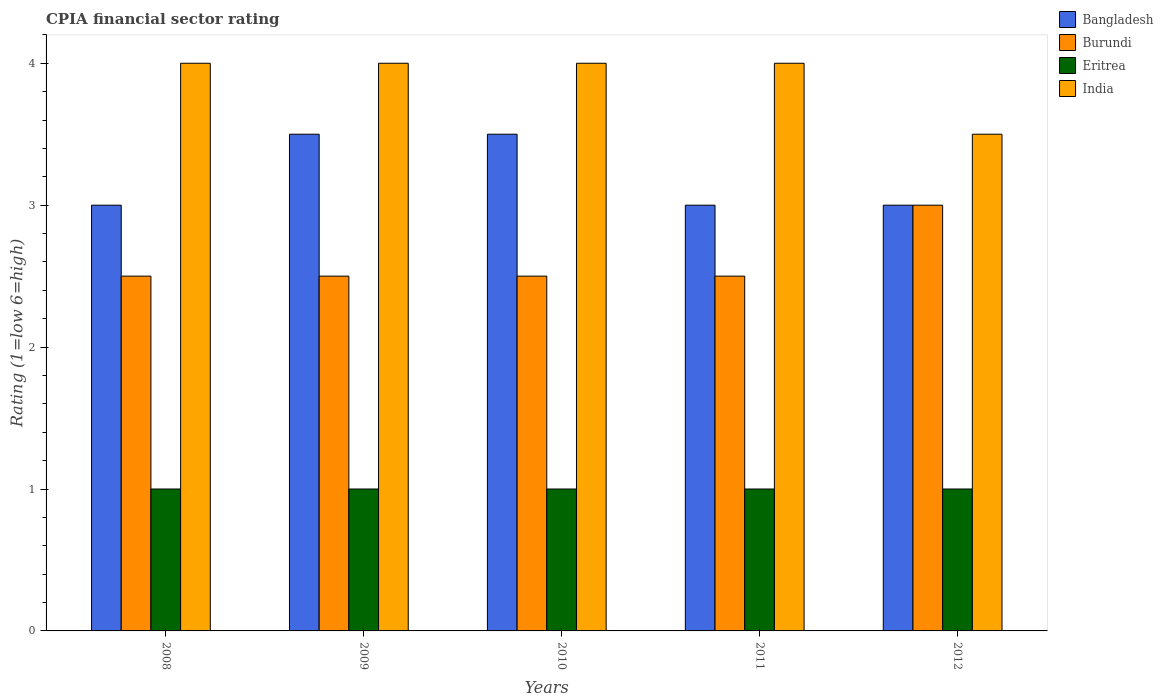How many bars are there on the 4th tick from the right?
Your answer should be very brief. 4. In how many cases, is the number of bars for a given year not equal to the number of legend labels?
Offer a very short reply. 0. What is the total CPIA rating in Bangladesh in the graph?
Your answer should be compact. 16. What is the difference between the CPIA rating in Eritrea in 2009 and that in 2010?
Your answer should be very brief. 0. What is the difference between the CPIA rating in Burundi in 2011 and the CPIA rating in Bangladesh in 2009?
Your response must be concise. -1. What is the average CPIA rating in Eritrea per year?
Your answer should be compact. 1. In the year 2012, what is the difference between the CPIA rating in Eritrea and CPIA rating in Bangladesh?
Your answer should be compact. -2. What is the ratio of the CPIA rating in Eritrea in 2009 to that in 2012?
Give a very brief answer. 1. What is the difference between the highest and the second highest CPIA rating in Eritrea?
Give a very brief answer. 0. What does the 2nd bar from the left in 2008 represents?
Your answer should be very brief. Burundi. What does the 4th bar from the right in 2012 represents?
Your response must be concise. Bangladesh. Is it the case that in every year, the sum of the CPIA rating in Bangladesh and CPIA rating in India is greater than the CPIA rating in Eritrea?
Keep it short and to the point. Yes. How many bars are there?
Provide a succinct answer. 20. How many years are there in the graph?
Provide a succinct answer. 5. What is the difference between two consecutive major ticks on the Y-axis?
Ensure brevity in your answer.  1. What is the title of the graph?
Give a very brief answer. CPIA financial sector rating. Does "Samoa" appear as one of the legend labels in the graph?
Ensure brevity in your answer.  No. What is the label or title of the X-axis?
Your answer should be very brief. Years. What is the label or title of the Y-axis?
Offer a very short reply. Rating (1=low 6=high). What is the Rating (1=low 6=high) of Eritrea in 2008?
Keep it short and to the point. 1. What is the Rating (1=low 6=high) in Eritrea in 2009?
Provide a succinct answer. 1. What is the Rating (1=low 6=high) in Burundi in 2010?
Provide a short and direct response. 2.5. What is the Rating (1=low 6=high) in Eritrea in 2010?
Give a very brief answer. 1. What is the Rating (1=low 6=high) of India in 2010?
Keep it short and to the point. 4. What is the Rating (1=low 6=high) of Burundi in 2012?
Your response must be concise. 3. What is the Rating (1=low 6=high) in India in 2012?
Offer a terse response. 3.5. Across all years, what is the maximum Rating (1=low 6=high) of Bangladesh?
Ensure brevity in your answer.  3.5. Across all years, what is the maximum Rating (1=low 6=high) of Burundi?
Give a very brief answer. 3. Across all years, what is the maximum Rating (1=low 6=high) in Eritrea?
Your response must be concise. 1. Across all years, what is the maximum Rating (1=low 6=high) of India?
Give a very brief answer. 4. Across all years, what is the minimum Rating (1=low 6=high) of Bangladesh?
Provide a succinct answer. 3. Across all years, what is the minimum Rating (1=low 6=high) of Eritrea?
Offer a very short reply. 1. What is the total Rating (1=low 6=high) of Bangladesh in the graph?
Keep it short and to the point. 16. What is the total Rating (1=low 6=high) in Eritrea in the graph?
Provide a short and direct response. 5. What is the difference between the Rating (1=low 6=high) of Eritrea in 2008 and that in 2009?
Provide a succinct answer. 0. What is the difference between the Rating (1=low 6=high) in Bangladesh in 2008 and that in 2010?
Your answer should be very brief. -0.5. What is the difference between the Rating (1=low 6=high) in Eritrea in 2008 and that in 2010?
Your response must be concise. 0. What is the difference between the Rating (1=low 6=high) in India in 2008 and that in 2010?
Offer a very short reply. 0. What is the difference between the Rating (1=low 6=high) in India in 2008 and that in 2011?
Offer a very short reply. 0. What is the difference between the Rating (1=low 6=high) in Bangladesh in 2008 and that in 2012?
Provide a succinct answer. 0. What is the difference between the Rating (1=low 6=high) of Eritrea in 2008 and that in 2012?
Provide a short and direct response. 0. What is the difference between the Rating (1=low 6=high) of India in 2008 and that in 2012?
Keep it short and to the point. 0.5. What is the difference between the Rating (1=low 6=high) in Bangladesh in 2009 and that in 2010?
Provide a short and direct response. 0. What is the difference between the Rating (1=low 6=high) in Eritrea in 2009 and that in 2010?
Keep it short and to the point. 0. What is the difference between the Rating (1=low 6=high) in Burundi in 2009 and that in 2011?
Your answer should be very brief. 0. What is the difference between the Rating (1=low 6=high) of Bangladesh in 2009 and that in 2012?
Give a very brief answer. 0.5. What is the difference between the Rating (1=low 6=high) of India in 2009 and that in 2012?
Offer a terse response. 0.5. What is the difference between the Rating (1=low 6=high) in Bangladesh in 2010 and that in 2011?
Provide a short and direct response. 0.5. What is the difference between the Rating (1=low 6=high) of India in 2010 and that in 2011?
Offer a very short reply. 0. What is the difference between the Rating (1=low 6=high) in Burundi in 2010 and that in 2012?
Ensure brevity in your answer.  -0.5. What is the difference between the Rating (1=low 6=high) in Eritrea in 2010 and that in 2012?
Your answer should be compact. 0. What is the difference between the Rating (1=low 6=high) in Eritrea in 2011 and that in 2012?
Your response must be concise. 0. What is the difference between the Rating (1=low 6=high) of India in 2011 and that in 2012?
Provide a succinct answer. 0.5. What is the difference between the Rating (1=low 6=high) in Bangladesh in 2008 and the Rating (1=low 6=high) in Burundi in 2009?
Ensure brevity in your answer.  0.5. What is the difference between the Rating (1=low 6=high) of Burundi in 2008 and the Rating (1=low 6=high) of India in 2009?
Your response must be concise. -1.5. What is the difference between the Rating (1=low 6=high) of Eritrea in 2008 and the Rating (1=low 6=high) of India in 2009?
Give a very brief answer. -3. What is the difference between the Rating (1=low 6=high) in Bangladesh in 2008 and the Rating (1=low 6=high) in Burundi in 2010?
Your response must be concise. 0.5. What is the difference between the Rating (1=low 6=high) of Bangladesh in 2008 and the Rating (1=low 6=high) of Eritrea in 2010?
Provide a succinct answer. 2. What is the difference between the Rating (1=low 6=high) of Burundi in 2008 and the Rating (1=low 6=high) of India in 2010?
Give a very brief answer. -1.5. What is the difference between the Rating (1=low 6=high) of Eritrea in 2008 and the Rating (1=low 6=high) of India in 2010?
Your answer should be compact. -3. What is the difference between the Rating (1=low 6=high) in Burundi in 2008 and the Rating (1=low 6=high) in India in 2011?
Keep it short and to the point. -1.5. What is the difference between the Rating (1=low 6=high) of Bangladesh in 2008 and the Rating (1=low 6=high) of Burundi in 2012?
Your answer should be very brief. 0. What is the difference between the Rating (1=low 6=high) in Bangladesh in 2008 and the Rating (1=low 6=high) in Eritrea in 2012?
Make the answer very short. 2. What is the difference between the Rating (1=low 6=high) in Bangladesh in 2008 and the Rating (1=low 6=high) in India in 2012?
Offer a terse response. -0.5. What is the difference between the Rating (1=low 6=high) of Eritrea in 2008 and the Rating (1=low 6=high) of India in 2012?
Ensure brevity in your answer.  -2.5. What is the difference between the Rating (1=low 6=high) of Bangladesh in 2009 and the Rating (1=low 6=high) of Eritrea in 2010?
Provide a short and direct response. 2.5. What is the difference between the Rating (1=low 6=high) of Burundi in 2009 and the Rating (1=low 6=high) of India in 2010?
Keep it short and to the point. -1.5. What is the difference between the Rating (1=low 6=high) of Eritrea in 2009 and the Rating (1=low 6=high) of India in 2010?
Give a very brief answer. -3. What is the difference between the Rating (1=low 6=high) of Bangladesh in 2009 and the Rating (1=low 6=high) of India in 2011?
Offer a very short reply. -0.5. What is the difference between the Rating (1=low 6=high) in Bangladesh in 2009 and the Rating (1=low 6=high) in Burundi in 2012?
Offer a terse response. 0.5. What is the difference between the Rating (1=low 6=high) in Bangladesh in 2009 and the Rating (1=low 6=high) in Eritrea in 2012?
Give a very brief answer. 2.5. What is the difference between the Rating (1=low 6=high) of Bangladesh in 2009 and the Rating (1=low 6=high) of India in 2012?
Keep it short and to the point. 0. What is the difference between the Rating (1=low 6=high) of Burundi in 2009 and the Rating (1=low 6=high) of Eritrea in 2012?
Offer a very short reply. 1.5. What is the difference between the Rating (1=low 6=high) in Burundi in 2009 and the Rating (1=low 6=high) in India in 2012?
Your response must be concise. -1. What is the difference between the Rating (1=low 6=high) in Eritrea in 2009 and the Rating (1=low 6=high) in India in 2012?
Provide a short and direct response. -2.5. What is the difference between the Rating (1=low 6=high) in Burundi in 2010 and the Rating (1=low 6=high) in India in 2011?
Offer a terse response. -1.5. What is the difference between the Rating (1=low 6=high) in Eritrea in 2010 and the Rating (1=low 6=high) in India in 2011?
Provide a short and direct response. -3. What is the difference between the Rating (1=low 6=high) of Bangladesh in 2010 and the Rating (1=low 6=high) of Eritrea in 2012?
Offer a terse response. 2.5. What is the difference between the Rating (1=low 6=high) in Bangladesh in 2010 and the Rating (1=low 6=high) in India in 2012?
Provide a succinct answer. 0. What is the difference between the Rating (1=low 6=high) in Burundi in 2010 and the Rating (1=low 6=high) in Eritrea in 2012?
Keep it short and to the point. 1.5. What is the difference between the Rating (1=low 6=high) in Burundi in 2010 and the Rating (1=low 6=high) in India in 2012?
Your answer should be compact. -1. What is the difference between the Rating (1=low 6=high) in Eritrea in 2010 and the Rating (1=low 6=high) in India in 2012?
Keep it short and to the point. -2.5. What is the difference between the Rating (1=low 6=high) of Bangladesh in 2011 and the Rating (1=low 6=high) of Burundi in 2012?
Make the answer very short. 0. What is the difference between the Rating (1=low 6=high) in Bangladesh in 2011 and the Rating (1=low 6=high) in India in 2012?
Ensure brevity in your answer.  -0.5. What is the average Rating (1=low 6=high) of Eritrea per year?
Your answer should be very brief. 1. In the year 2008, what is the difference between the Rating (1=low 6=high) of Bangladesh and Rating (1=low 6=high) of Burundi?
Keep it short and to the point. 0.5. In the year 2008, what is the difference between the Rating (1=low 6=high) of Bangladesh and Rating (1=low 6=high) of Eritrea?
Ensure brevity in your answer.  2. In the year 2008, what is the difference between the Rating (1=low 6=high) of Bangladesh and Rating (1=low 6=high) of India?
Make the answer very short. -1. In the year 2008, what is the difference between the Rating (1=low 6=high) of Burundi and Rating (1=low 6=high) of Eritrea?
Provide a succinct answer. 1.5. In the year 2008, what is the difference between the Rating (1=low 6=high) in Burundi and Rating (1=low 6=high) in India?
Give a very brief answer. -1.5. In the year 2009, what is the difference between the Rating (1=low 6=high) of Bangladesh and Rating (1=low 6=high) of Burundi?
Your answer should be compact. 1. In the year 2009, what is the difference between the Rating (1=low 6=high) in Bangladesh and Rating (1=low 6=high) in India?
Your answer should be compact. -0.5. In the year 2009, what is the difference between the Rating (1=low 6=high) in Burundi and Rating (1=low 6=high) in Eritrea?
Ensure brevity in your answer.  1.5. In the year 2009, what is the difference between the Rating (1=low 6=high) of Burundi and Rating (1=low 6=high) of India?
Keep it short and to the point. -1.5. In the year 2009, what is the difference between the Rating (1=low 6=high) of Eritrea and Rating (1=low 6=high) of India?
Ensure brevity in your answer.  -3. In the year 2010, what is the difference between the Rating (1=low 6=high) in Bangladesh and Rating (1=low 6=high) in Burundi?
Provide a short and direct response. 1. In the year 2010, what is the difference between the Rating (1=low 6=high) in Bangladesh and Rating (1=low 6=high) in Eritrea?
Your answer should be compact. 2.5. In the year 2010, what is the difference between the Rating (1=low 6=high) in Bangladesh and Rating (1=low 6=high) in India?
Provide a succinct answer. -0.5. In the year 2010, what is the difference between the Rating (1=low 6=high) in Burundi and Rating (1=low 6=high) in Eritrea?
Your answer should be very brief. 1.5. In the year 2010, what is the difference between the Rating (1=low 6=high) in Burundi and Rating (1=low 6=high) in India?
Your response must be concise. -1.5. In the year 2010, what is the difference between the Rating (1=low 6=high) in Eritrea and Rating (1=low 6=high) in India?
Your response must be concise. -3. In the year 2011, what is the difference between the Rating (1=low 6=high) of Bangladesh and Rating (1=low 6=high) of Burundi?
Offer a very short reply. 0.5. In the year 2011, what is the difference between the Rating (1=low 6=high) of Eritrea and Rating (1=low 6=high) of India?
Your answer should be very brief. -3. In the year 2012, what is the difference between the Rating (1=low 6=high) of Bangladesh and Rating (1=low 6=high) of Eritrea?
Make the answer very short. 2. In the year 2012, what is the difference between the Rating (1=low 6=high) of Bangladesh and Rating (1=low 6=high) of India?
Offer a terse response. -0.5. In the year 2012, what is the difference between the Rating (1=low 6=high) of Burundi and Rating (1=low 6=high) of India?
Provide a succinct answer. -0.5. What is the ratio of the Rating (1=low 6=high) of Burundi in 2008 to that in 2009?
Ensure brevity in your answer.  1. What is the ratio of the Rating (1=low 6=high) of Bangladesh in 2008 to that in 2010?
Offer a terse response. 0.86. What is the ratio of the Rating (1=low 6=high) of Burundi in 2008 to that in 2010?
Ensure brevity in your answer.  1. What is the ratio of the Rating (1=low 6=high) of India in 2008 to that in 2010?
Your answer should be compact. 1. What is the ratio of the Rating (1=low 6=high) of Bangladesh in 2008 to that in 2011?
Your response must be concise. 1. What is the ratio of the Rating (1=low 6=high) in Burundi in 2008 to that in 2011?
Offer a very short reply. 1. What is the ratio of the Rating (1=low 6=high) of Bangladesh in 2009 to that in 2010?
Provide a succinct answer. 1. What is the ratio of the Rating (1=low 6=high) of Eritrea in 2009 to that in 2010?
Offer a terse response. 1. What is the ratio of the Rating (1=low 6=high) in Bangladesh in 2009 to that in 2011?
Provide a succinct answer. 1.17. What is the ratio of the Rating (1=low 6=high) of India in 2009 to that in 2011?
Your answer should be compact. 1. What is the ratio of the Rating (1=low 6=high) of Bangladesh in 2009 to that in 2012?
Offer a very short reply. 1.17. What is the ratio of the Rating (1=low 6=high) of Burundi in 2009 to that in 2012?
Keep it short and to the point. 0.83. What is the ratio of the Rating (1=low 6=high) of Eritrea in 2009 to that in 2012?
Your answer should be very brief. 1. What is the ratio of the Rating (1=low 6=high) of Bangladesh in 2010 to that in 2011?
Ensure brevity in your answer.  1.17. What is the ratio of the Rating (1=low 6=high) of Burundi in 2010 to that in 2011?
Your answer should be very brief. 1. What is the ratio of the Rating (1=low 6=high) of Eritrea in 2010 to that in 2011?
Ensure brevity in your answer.  1. What is the ratio of the Rating (1=low 6=high) of Bangladesh in 2010 to that in 2012?
Ensure brevity in your answer.  1.17. What is the ratio of the Rating (1=low 6=high) in Burundi in 2010 to that in 2012?
Keep it short and to the point. 0.83. What is the ratio of the Rating (1=low 6=high) of Eritrea in 2010 to that in 2012?
Provide a succinct answer. 1. What is the ratio of the Rating (1=low 6=high) in India in 2010 to that in 2012?
Ensure brevity in your answer.  1.14. What is the ratio of the Rating (1=low 6=high) in Bangladesh in 2011 to that in 2012?
Offer a terse response. 1. What is the ratio of the Rating (1=low 6=high) of Burundi in 2011 to that in 2012?
Give a very brief answer. 0.83. What is the ratio of the Rating (1=low 6=high) of Eritrea in 2011 to that in 2012?
Provide a succinct answer. 1. What is the difference between the highest and the second highest Rating (1=low 6=high) of Bangladesh?
Keep it short and to the point. 0. What is the difference between the highest and the second highest Rating (1=low 6=high) of Burundi?
Offer a terse response. 0.5. What is the difference between the highest and the second highest Rating (1=low 6=high) in India?
Your answer should be compact. 0. What is the difference between the highest and the lowest Rating (1=low 6=high) in India?
Give a very brief answer. 0.5. 